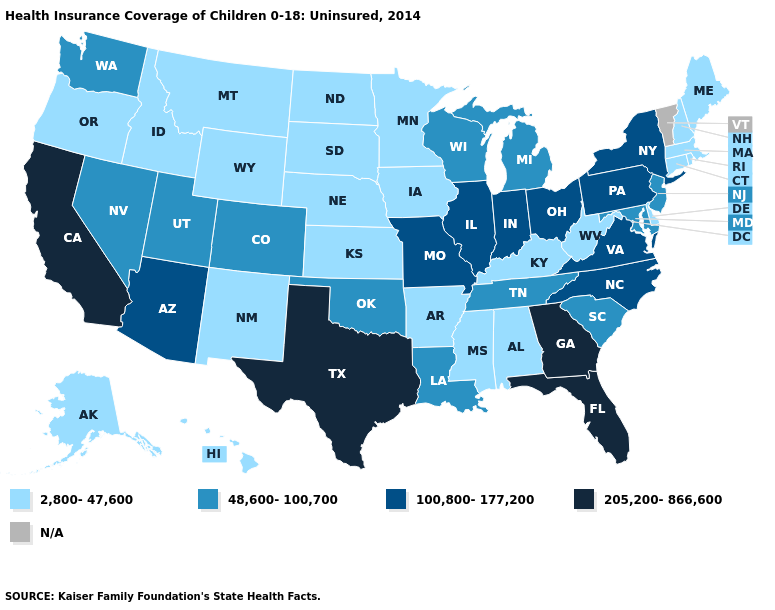Does Florida have the highest value in the USA?
Keep it brief. Yes. Name the states that have a value in the range 2,800-47,600?
Short answer required. Alabama, Alaska, Arkansas, Connecticut, Delaware, Hawaii, Idaho, Iowa, Kansas, Kentucky, Maine, Massachusetts, Minnesota, Mississippi, Montana, Nebraska, New Hampshire, New Mexico, North Dakota, Oregon, Rhode Island, South Dakota, West Virginia, Wyoming. What is the value of Kansas?
Concise answer only. 2,800-47,600. Name the states that have a value in the range N/A?
Quick response, please. Vermont. Name the states that have a value in the range N/A?
Concise answer only. Vermont. Does Pennsylvania have the lowest value in the USA?
Short answer required. No. What is the value of Tennessee?
Concise answer only. 48,600-100,700. Which states hav the highest value in the West?
Write a very short answer. California. Name the states that have a value in the range 2,800-47,600?
Keep it brief. Alabama, Alaska, Arkansas, Connecticut, Delaware, Hawaii, Idaho, Iowa, Kansas, Kentucky, Maine, Massachusetts, Minnesota, Mississippi, Montana, Nebraska, New Hampshire, New Mexico, North Dakota, Oregon, Rhode Island, South Dakota, West Virginia, Wyoming. What is the value of Maryland?
Keep it brief. 48,600-100,700. What is the value of Nevada?
Give a very brief answer. 48,600-100,700. Does Minnesota have the highest value in the MidWest?
Quick response, please. No. What is the value of Ohio?
Concise answer only. 100,800-177,200. What is the value of Michigan?
Write a very short answer. 48,600-100,700. Does New York have the lowest value in the Northeast?
Quick response, please. No. 